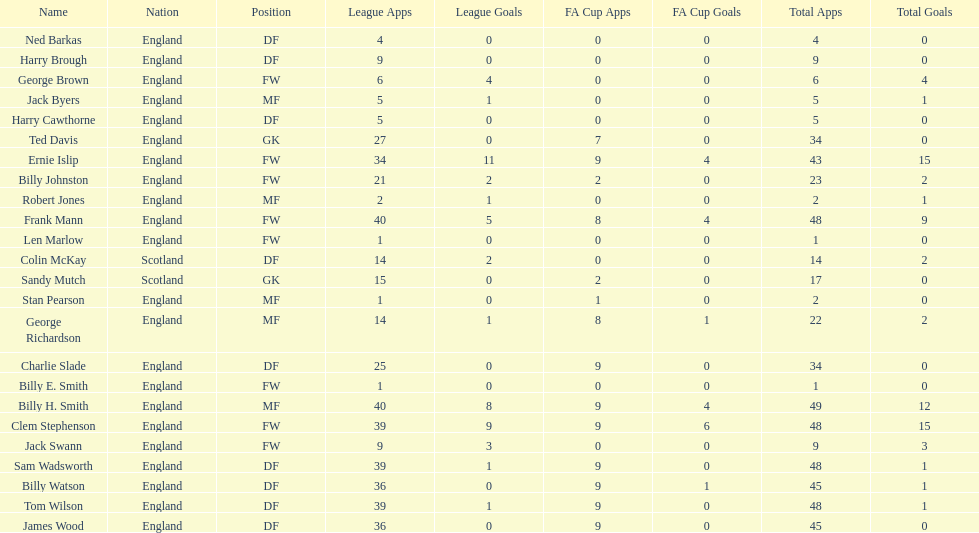Average number of goals scored by players from scotland 1. 